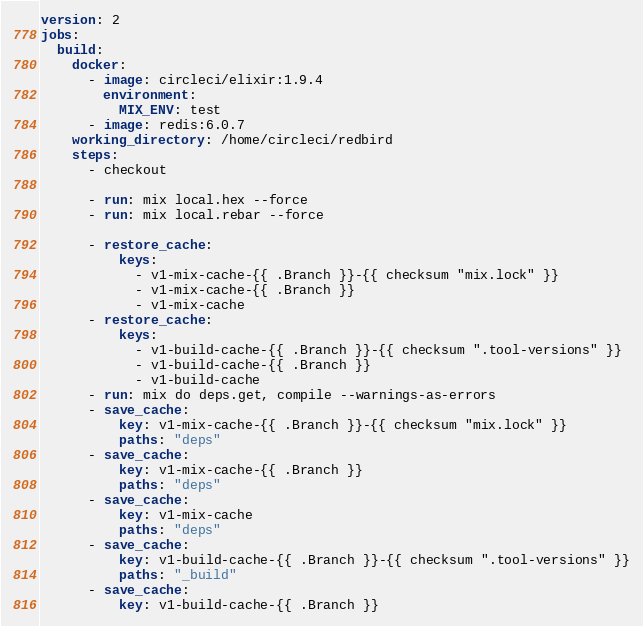Convert code to text. <code><loc_0><loc_0><loc_500><loc_500><_YAML_>version: 2
jobs:
  build:
    docker:
      - image: circleci/elixir:1.9.4
        environment:
          MIX_ENV: test
      - image: redis:6.0.7
    working_directory: /home/circleci/redbird
    steps:
      - checkout

      - run: mix local.hex --force
      - run: mix local.rebar --force

      - restore_cache:
          keys:
            - v1-mix-cache-{{ .Branch }}-{{ checksum "mix.lock" }}
            - v1-mix-cache-{{ .Branch }}
            - v1-mix-cache
      - restore_cache:
          keys:
            - v1-build-cache-{{ .Branch }}-{{ checksum ".tool-versions" }}
            - v1-build-cache-{{ .Branch }}
            - v1-build-cache
      - run: mix do deps.get, compile --warnings-as-errors
      - save_cache:
          key: v1-mix-cache-{{ .Branch }}-{{ checksum "mix.lock" }}
          paths: "deps"
      - save_cache:
          key: v1-mix-cache-{{ .Branch }}
          paths: "deps"
      - save_cache:
          key: v1-mix-cache
          paths: "deps"
      - save_cache:
          key: v1-build-cache-{{ .Branch }}-{{ checksum ".tool-versions" }}
          paths: "_build"
      - save_cache:
          key: v1-build-cache-{{ .Branch }}</code> 